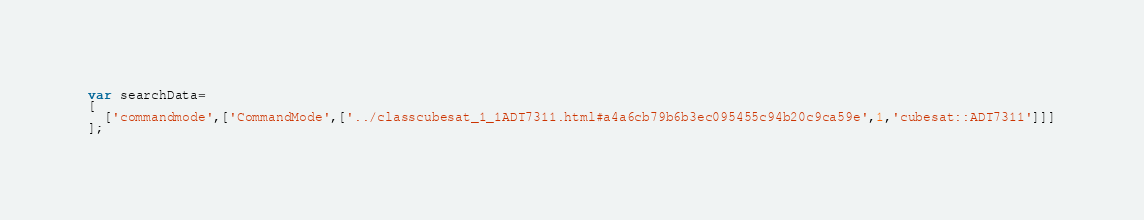Convert code to text. <code><loc_0><loc_0><loc_500><loc_500><_JavaScript_>var searchData=
[
  ['commandmode',['CommandMode',['../classcubesat_1_1ADT7311.html#a4a6cb79b6b3ec095455c94b20c9ca59e',1,'cubesat::ADT7311']]]
];
</code> 